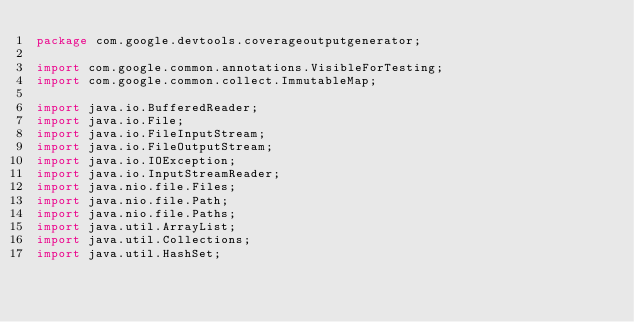Convert code to text. <code><loc_0><loc_0><loc_500><loc_500><_Java_>package com.google.devtools.coverageoutputgenerator;

import com.google.common.annotations.VisibleForTesting;
import com.google.common.collect.ImmutableMap;

import java.io.BufferedReader;
import java.io.File;
import java.io.FileInputStream;
import java.io.FileOutputStream;
import java.io.IOException;
import java.io.InputStreamReader;
import java.nio.file.Files;
import java.nio.file.Path;
import java.nio.file.Paths;
import java.util.ArrayList;
import java.util.Collections;
import java.util.HashSet;</code> 